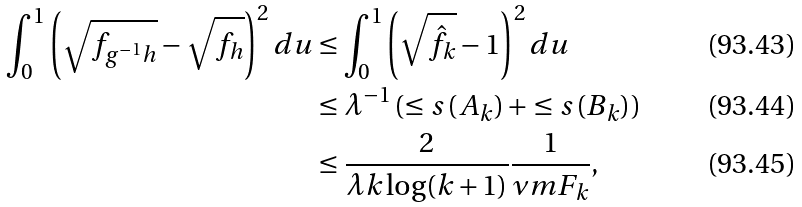<formula> <loc_0><loc_0><loc_500><loc_500>\int _ { 0 } ^ { 1 } \left ( \sqrt { f _ { g ^ { - 1 } h } } - \sqrt { f _ { h } } \right ) ^ { 2 } d u & \leq \int _ { 0 } ^ { 1 } \left ( \sqrt { \hat { f } _ { k } } - 1 \right ) ^ { 2 } d u \\ & \leq \lambda ^ { - 1 } \left ( \leq s \left ( A _ { k } \right ) + \leq s \left ( B _ { k } \right ) \right ) \\ & \leq \frac { 2 } { \lambda k \log ( k + 1 ) } \frac { 1 } { \nu m { F _ { k } } } ,</formula> 